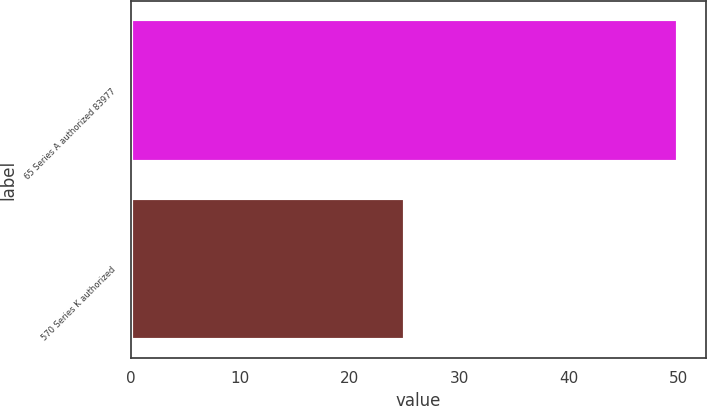Convert chart. <chart><loc_0><loc_0><loc_500><loc_500><bar_chart><fcel>65 Series A authorized 83977<fcel>570 Series K authorized<nl><fcel>50<fcel>25<nl></chart> 